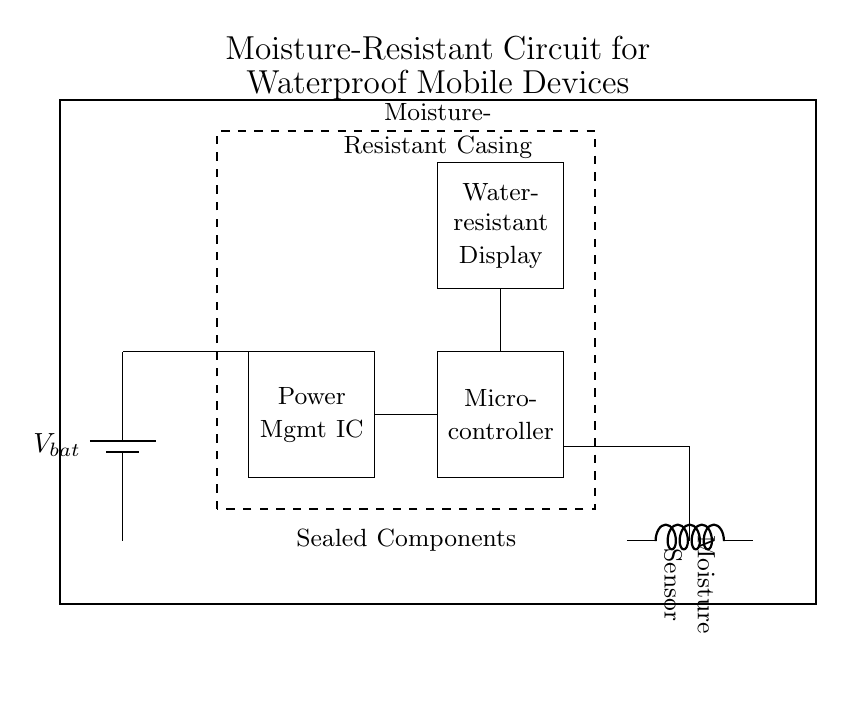What is the purpose of the moisture sensor in this circuit? The moisture sensor is used to detect the presence of moisture, which can trigger other actions in the circuit, such as alerting the microcontroller.
Answer: Detect moisture What is the voltage source in this circuit? The circuit shows a battery labeled as V bat, which serves as the voltage source providing power to the entire circuit.
Answer: V bat How is the display characterized in this circuit? The display is labeled as water-resistant, indicating it is designed to function effectively even in wet conditions, which is crucial for a waterproof mobile device.
Answer: Water-resistant display Which components are sealed according to the diagram? The diagram indicates that components like the battery, power management IC, and microcontroller are sealed, which protects them from moisture ingress.
Answer: Sealed components What is the main logic unit in this circuit? The microcontroller is the main logic unit in the circuit, processing data received from the moisture sensor and controlling other components accordingly.
Answer: Microcontroller How does the power management IC interact with other components? The power management IC regulates the voltage supplied from the battery to other components, ensuring they receive appropriate power levels for operation.
Answer: Regulates power supply 